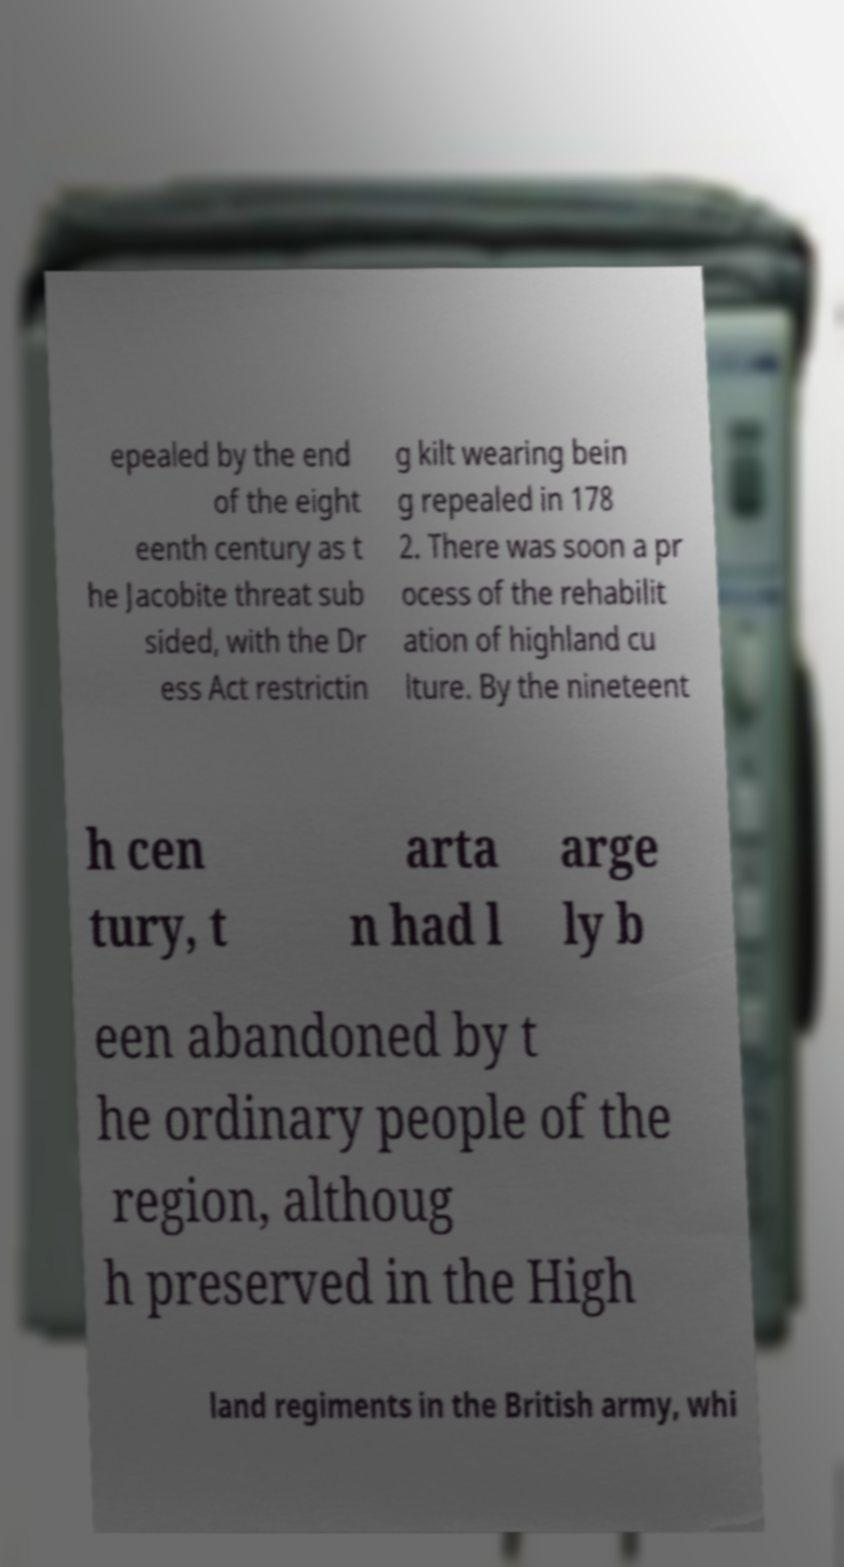Could you extract and type out the text from this image? epealed by the end of the eight eenth century as t he Jacobite threat sub sided, with the Dr ess Act restrictin g kilt wearing bein g repealed in 178 2. There was soon a pr ocess of the rehabilit ation of highland cu lture. By the nineteent h cen tury, t arta n had l arge ly b een abandoned by t he ordinary people of the region, althoug h preserved in the High land regiments in the British army, whi 